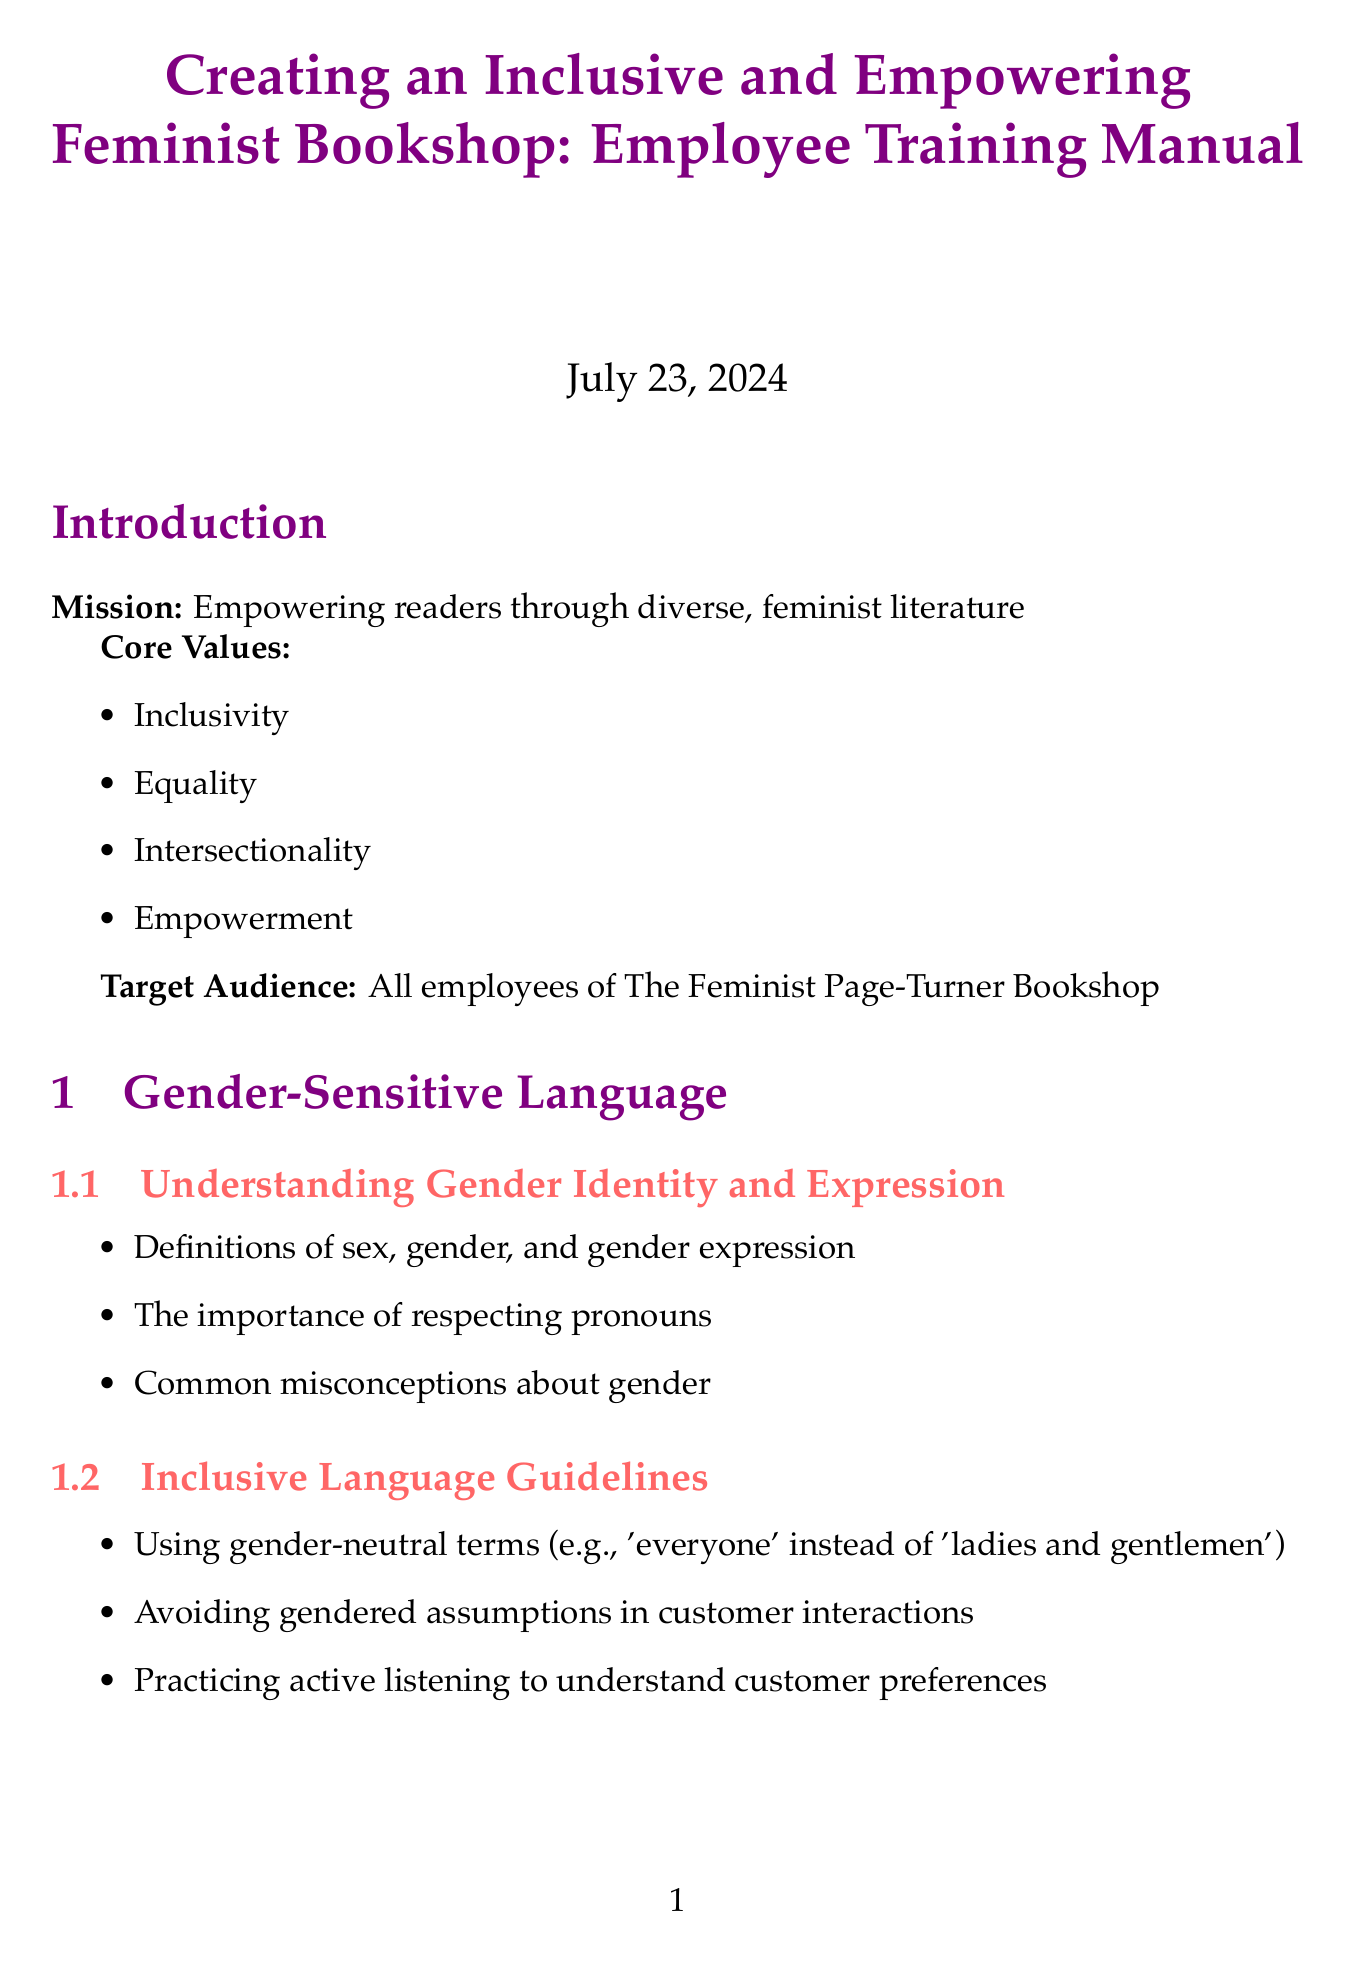What is the mission of the bookshop? The mission of the bookshop is stated in the introduction section, emphasizing the empowerment of readers.
Answer: Empowering readers through diverse, feminist literature What is the first section under Gender-Sensitive Language? The document lists sections under each chapter, and the first section in Gender-Sensitive Language is provided in the structure.
Answer: Understanding Gender Identity and Expression How many core values are listed in the manual? The core values are explicitly listed in the introduction section, providing a clear count.
Answer: Four What is an example of a de-escalation technique mentioned? The document provides several techniques for conflict resolution, including specific examples to illustrate methods.
Answer: Active listening and validation Name one of the local resources listed in the appendices. The appendices section enumerates various local resources available, which are included in a list.
Answer: Safe Haven House What kind of events does the manual suggest hosting for community engagement? The document specifies types of events that promote community interaction as part of its guidelines.
Answer: Workshops on feminist topics Which authors are included in the recommended reading list? The manual presents a reading list at the end, making it straightforward to identify the included authors.
Answer: Audre Lorde, Judith Butler, Roxane Gay, bell hooks, Chimamanda Ngozi Adichie What strategy is recommended for creating an anti-bias culture? The document outlines various strategies under the section on addressing bias, indicating effective practices.
Answer: Conducting regular bias training sessions 